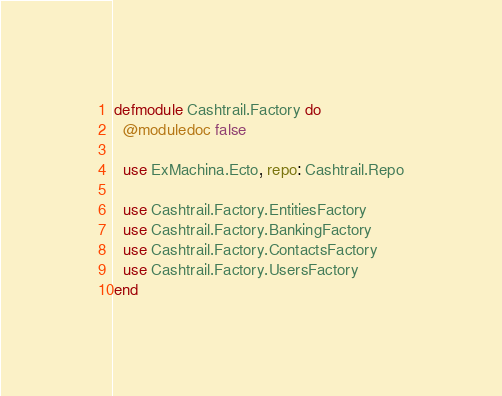<code> <loc_0><loc_0><loc_500><loc_500><_Elixir_>defmodule Cashtrail.Factory do
  @moduledoc false

  use ExMachina.Ecto, repo: Cashtrail.Repo

  use Cashtrail.Factory.EntitiesFactory
  use Cashtrail.Factory.BankingFactory
  use Cashtrail.Factory.ContactsFactory
  use Cashtrail.Factory.UsersFactory
end
</code> 